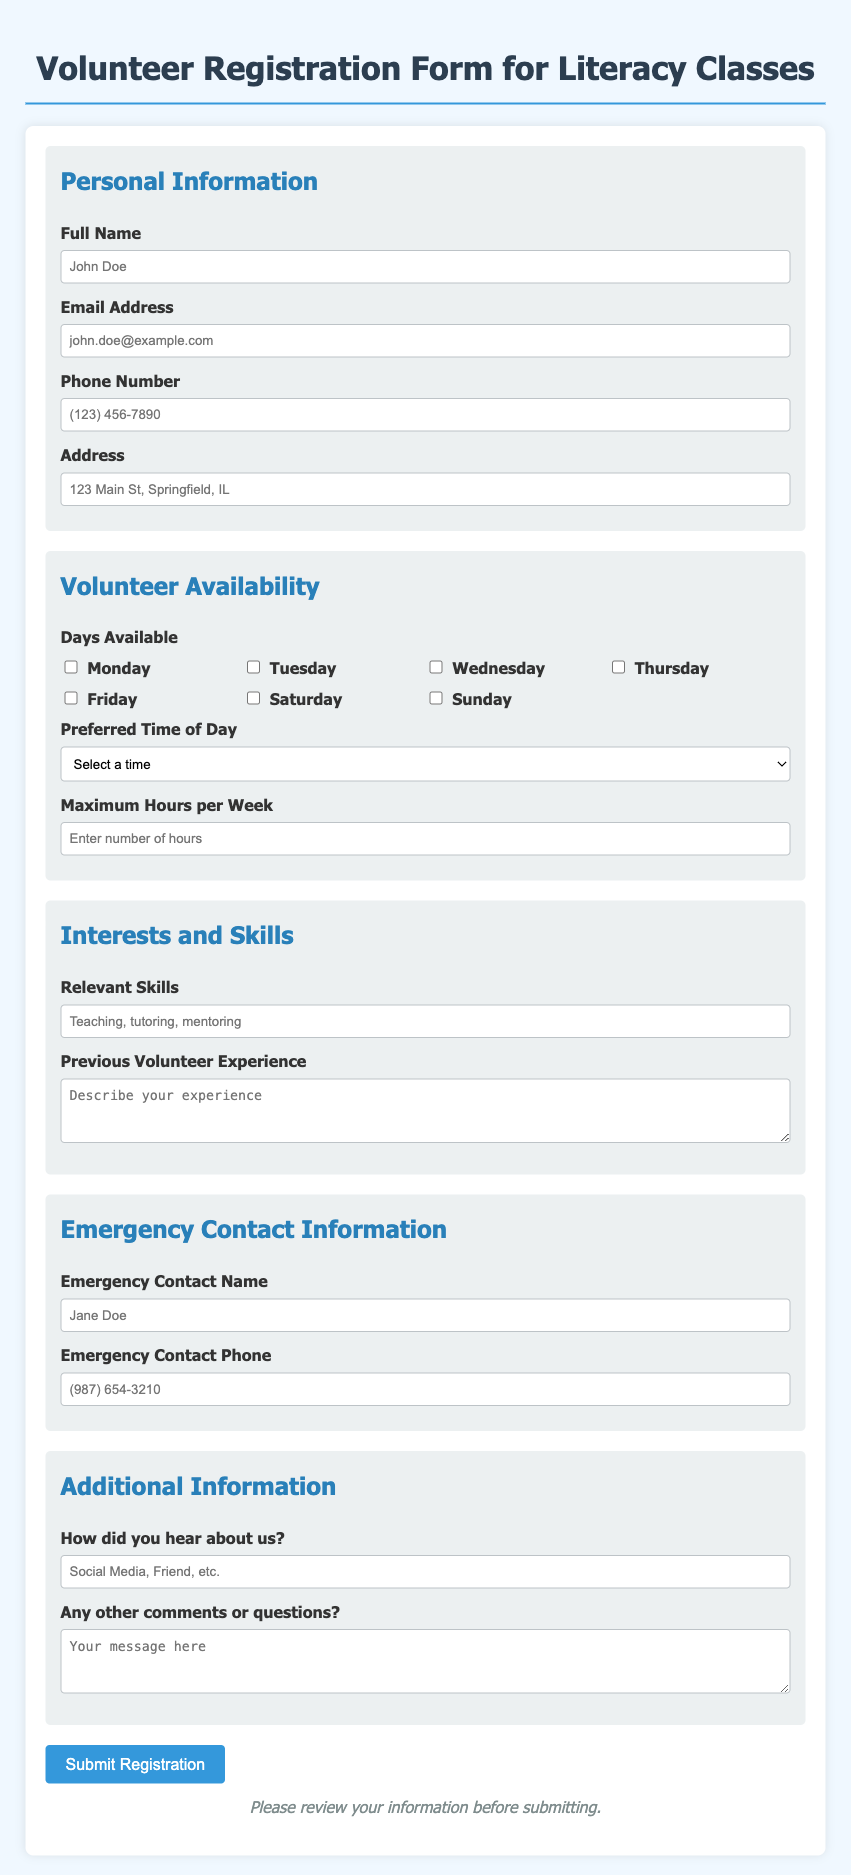What is the title of the form? The title is clearly stated at the top of the form, indicating its purpose for volunteer registration.
Answer: Volunteer Registration Form for Literacy Classes How many sections are in the form? The document includes various distinct parts, each focusing on a specific area of information, which can be counted for clarity.
Answer: 5 What is the maximum hours entry placeholder? The placeholder provides a hint to the type of input expected in the respective field.
Answer: Enter number of hours Which days can volunteers select for availability? This question requires identifying multiple choices that volunteers can check off in the corresponding section.
Answer: Monday, Tuesday, Wednesday, Thursday, Friday, Saturday, Sunday What is the required input for the emergency contact name? This asks for a specific piece of personal information that a volunteer must provide for safety purposes.
Answer: Jane Doe What type of experience description is asked from volunteers? This question reflects the expectation from the volunteers related to past involvement that's relevant to the role they are applying for.
Answer: Describe your experience How did the form request the volunteers to review their information? This highlights the importance placed on double-checking provided information before final submission.
Answer: Please review your information before submitting What is the preferred format for skills entry? The form suggests how volunteers can convey their relevant experience effectively through specified input.
Answer: Teaching, tutoring, mentoring 